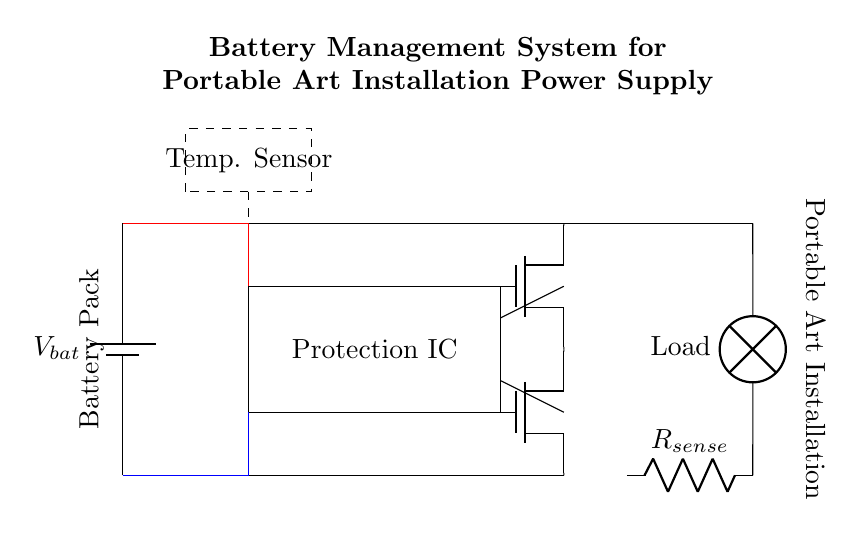What is the type of power source used in this circuit? The circuit uses a battery as a power source, indicated by the battery symbol labeled "V bat."
Answer: battery How many MOSFETs are present in the circuit? There are two MOSFETs used in this circuit, labeled Q1 and Q2.
Answer: two What is the function of the protection IC? The protection IC is responsible for preventing damage to the battery and load by managing conditions such as overcharging and over-discharging, ensuring safe operation.
Answer: managing battery safety What does the current sense resistor measure? The current sense resistor, labeled R sense, is used to measure the current flowing from the battery to the load, providing feedback for the protection circuit.
Answer: current flow Why is there a temperature sensor present in the circuit? The temperature sensor monitors the battery's temperature to prevent overheating, which is critical for safe battery management and can trigger protective actions if necessary.
Answer: monitor battery temperature What do the dashed lines represent in the circuit diagram? The dashed lines represent components that provide essential feedback to the protection IC, indicating connections for temperature monitoring and temperature sensing.
Answer: feedback connections What is the load component in the circuit? The load component is represented by a lamp, which is the device powered by the battery through the management system in this installation.
Answer: lamp 